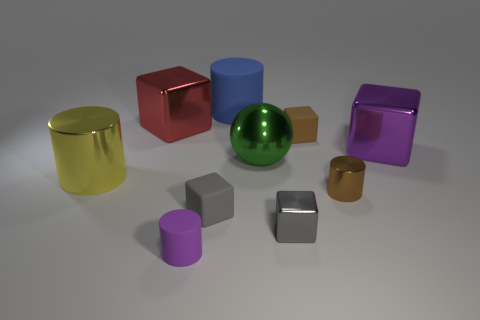Is there any other thing that is the same shape as the big green object?
Your answer should be very brief. No. What number of blue objects are large rubber cylinders or tiny rubber spheres?
Give a very brief answer. 1. Is there a red object that has the same size as the green metal ball?
Offer a terse response. Yes. How many big metal objects are there?
Provide a succinct answer. 4. How many large things are either yellow things or matte cylinders?
Your response must be concise. 2. What color is the small cube that is behind the small gray thing that is left of the matte cylinder that is behind the small gray rubber object?
Offer a terse response. Brown. How many other things are the same color as the small shiny block?
Ensure brevity in your answer.  1. What number of rubber objects are either red objects or small brown objects?
Your answer should be compact. 1. There is a large metallic cube that is right of the red thing; is its color the same as the rubber block that is on the left side of the big rubber object?
Offer a very short reply. No. Are there any other things that have the same material as the large red block?
Your response must be concise. Yes. 